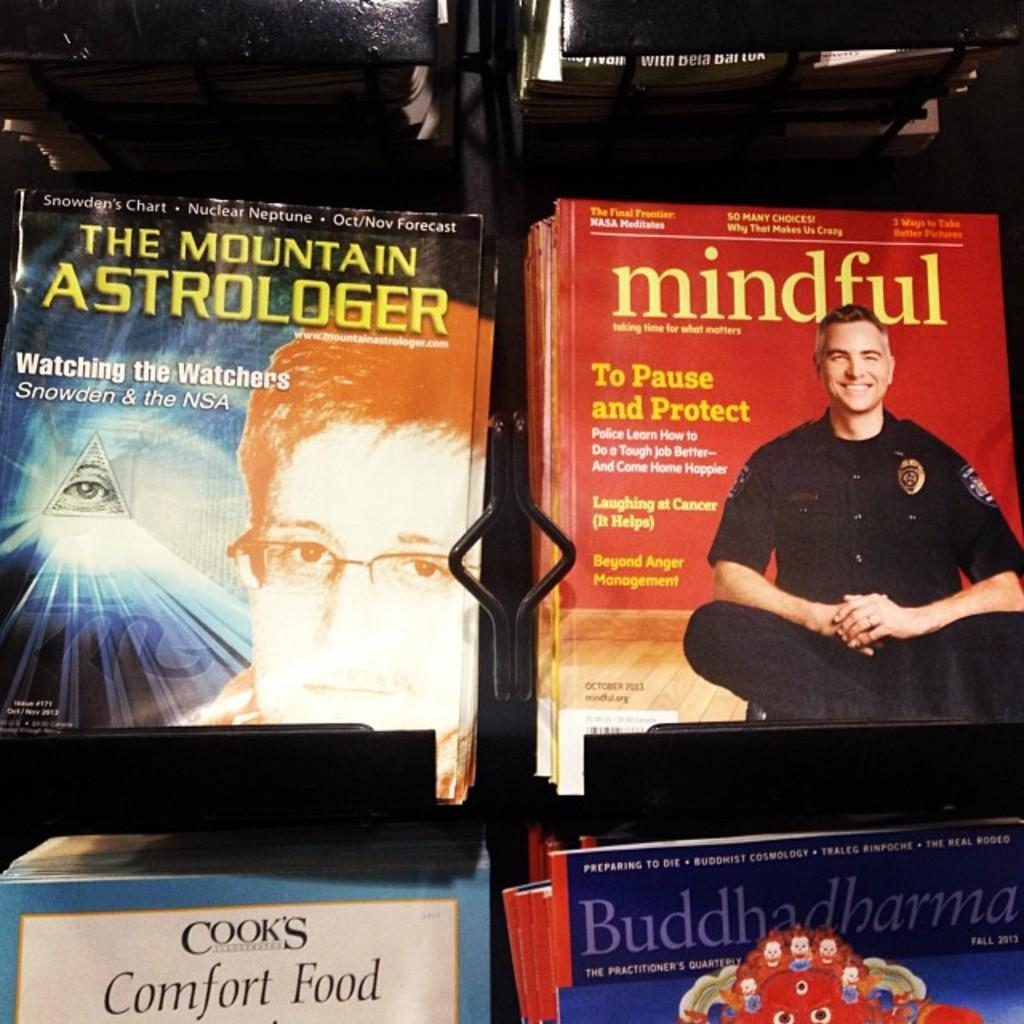<image>
Provide a brief description of the given image. a bunch of magazines with the words Mindful on it 